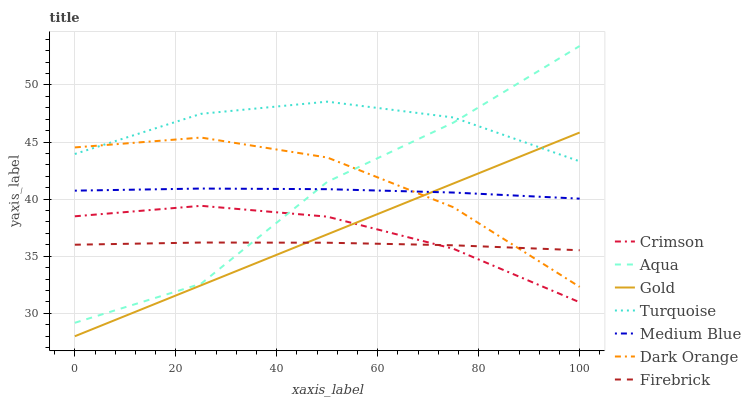Does Firebrick have the minimum area under the curve?
Answer yes or no. Yes. Does Turquoise have the maximum area under the curve?
Answer yes or no. Yes. Does Gold have the minimum area under the curve?
Answer yes or no. No. Does Gold have the maximum area under the curve?
Answer yes or no. No. Is Gold the smoothest?
Answer yes or no. Yes. Is Aqua the roughest?
Answer yes or no. Yes. Is Turquoise the smoothest?
Answer yes or no. No. Is Turquoise the roughest?
Answer yes or no. No. Does Gold have the lowest value?
Answer yes or no. Yes. Does Turquoise have the lowest value?
Answer yes or no. No. Does Aqua have the highest value?
Answer yes or no. Yes. Does Turquoise have the highest value?
Answer yes or no. No. Is Crimson less than Medium Blue?
Answer yes or no. Yes. Is Dark Orange greater than Crimson?
Answer yes or no. Yes. Does Medium Blue intersect Aqua?
Answer yes or no. Yes. Is Medium Blue less than Aqua?
Answer yes or no. No. Is Medium Blue greater than Aqua?
Answer yes or no. No. Does Crimson intersect Medium Blue?
Answer yes or no. No. 